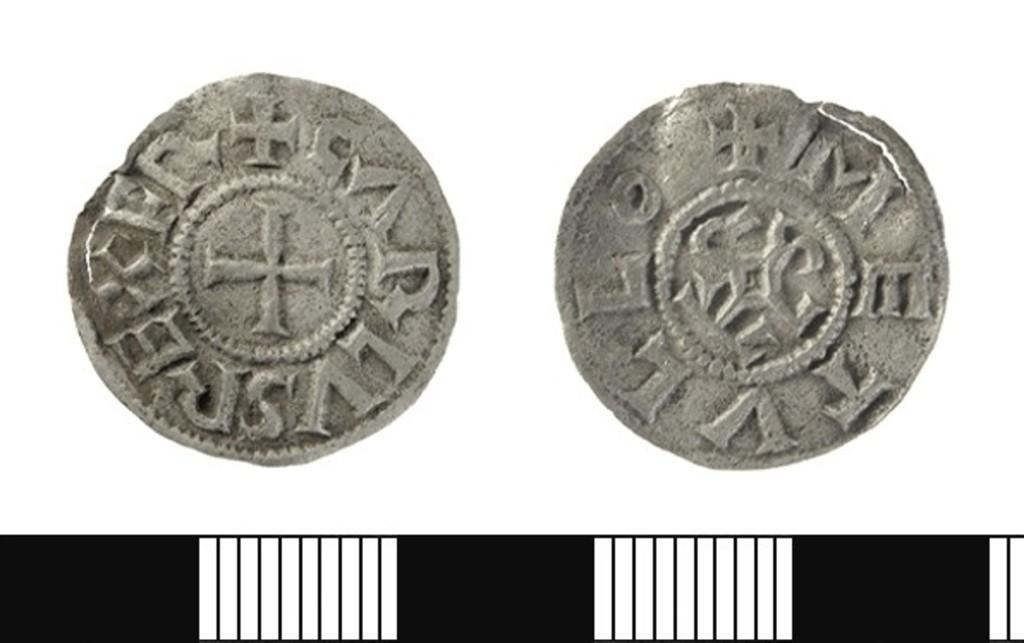Provide a one-sentence caption for the provided image. Coins have letters on them including an E and T. 